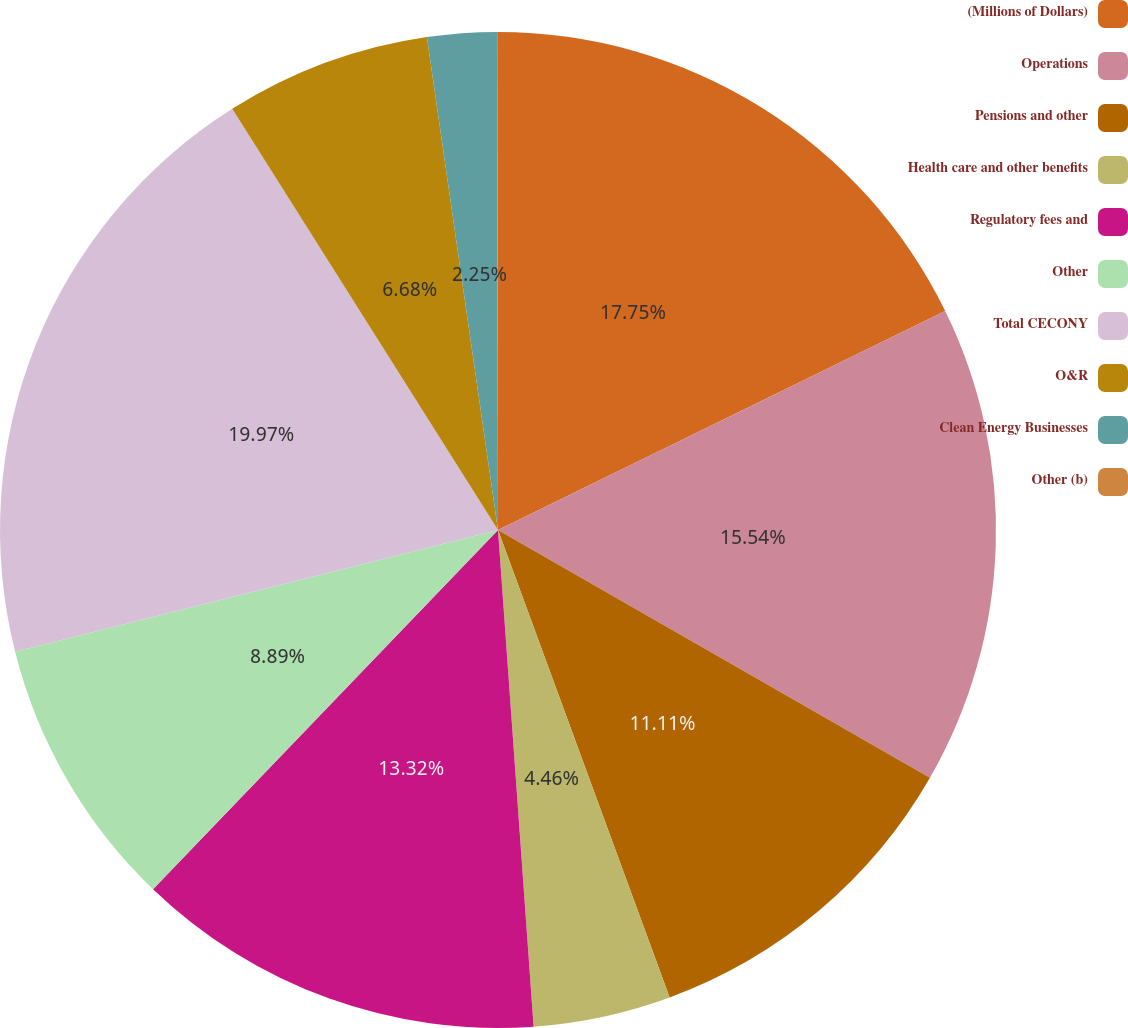<chart> <loc_0><loc_0><loc_500><loc_500><pie_chart><fcel>(Millions of Dollars)<fcel>Operations<fcel>Pensions and other<fcel>Health care and other benefits<fcel>Regulatory fees and<fcel>Other<fcel>Total CECONY<fcel>O&R<fcel>Clean Energy Businesses<fcel>Other (b)<nl><fcel>17.75%<fcel>15.54%<fcel>11.11%<fcel>4.46%<fcel>13.32%<fcel>8.89%<fcel>19.97%<fcel>6.68%<fcel>2.25%<fcel>0.03%<nl></chart> 